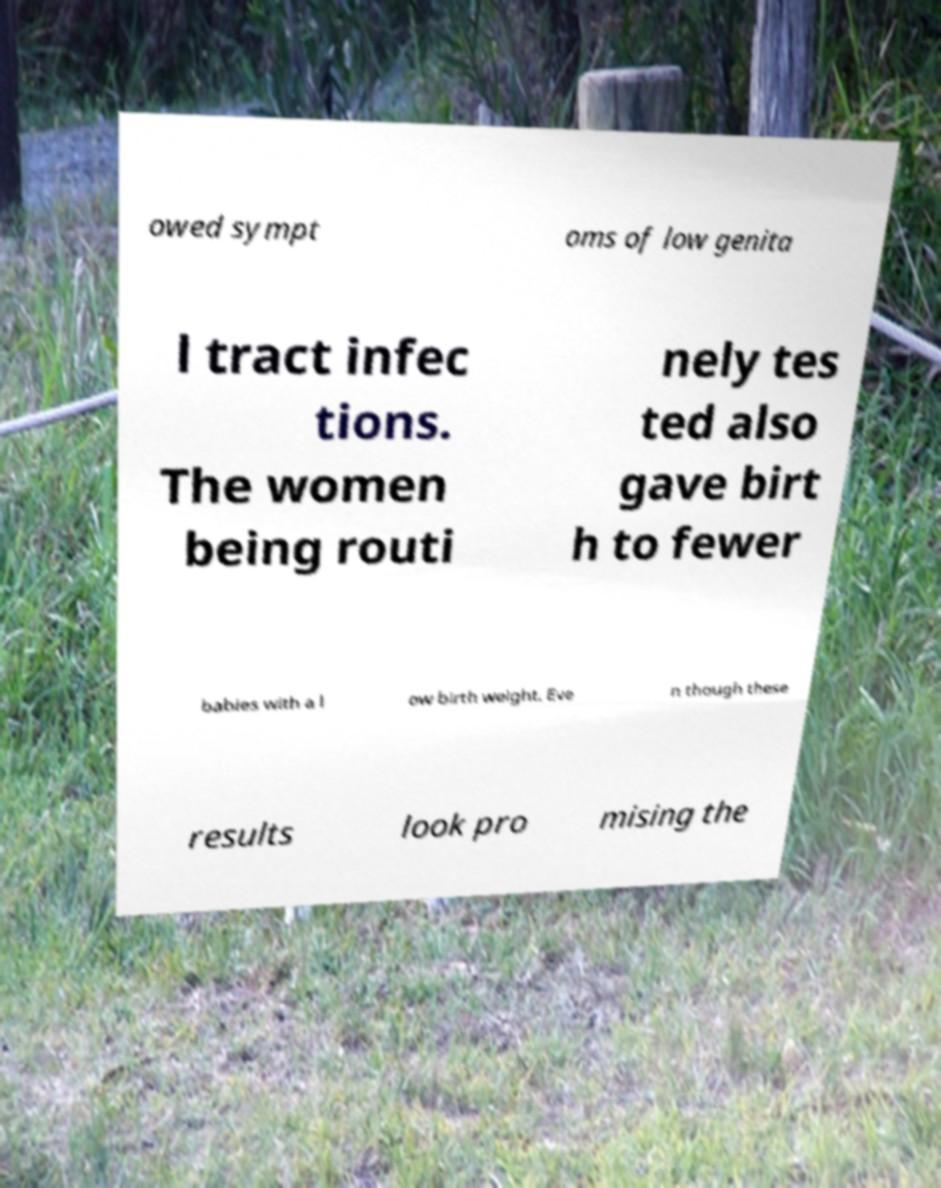There's text embedded in this image that I need extracted. Can you transcribe it verbatim? owed sympt oms of low genita l tract infec tions. The women being routi nely tes ted also gave birt h to fewer babies with a l ow birth weight. Eve n though these results look pro mising the 